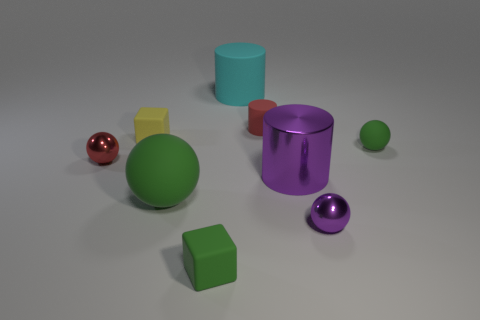There is a cyan object that is the same shape as the red matte thing; what is it made of?
Give a very brief answer. Rubber. Are there any other things that have the same size as the purple ball?
Offer a very short reply. Yes. Does the sphere on the left side of the large ball have the same color as the cylinder that is in front of the yellow matte object?
Your response must be concise. No. The tiny red metallic object is what shape?
Make the answer very short. Sphere. Is the number of small purple metallic things that are right of the small purple metallic thing greater than the number of cyan objects?
Give a very brief answer. No. What shape is the tiny red object right of the small yellow cube?
Offer a very short reply. Cylinder. How many other things are there of the same shape as the big purple shiny object?
Ensure brevity in your answer.  2. Are the small sphere left of the small green block and the big green sphere made of the same material?
Give a very brief answer. No. Are there the same number of green rubber spheres on the left side of the big green matte thing and small yellow matte objects that are to the right of the cyan cylinder?
Provide a succinct answer. Yes. What size is the red object behind the tiny matte sphere?
Ensure brevity in your answer.  Small. 